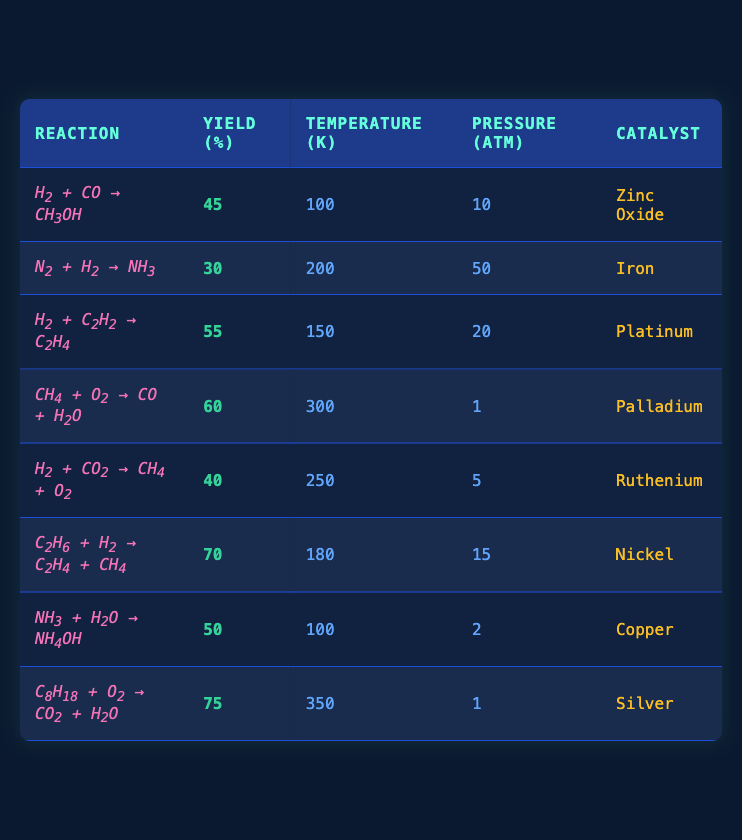What is the yield of the reaction involving H2 and CO? The yield for the reaction "H2 + CO -> CH3OH" is listed directly in the table as 45%.
Answer: 45% What catalyst is used in the reaction producing CH3OH? The reaction "H2 + CO -> CH3OH" uses Zinc Oxide as the catalyst, which is specified in the table.
Answer: Zinc Oxide Which reaction has the highest yield? The last row in the table shows that "C8H18 + O2 -> CO2 + H2O" has the highest yield of 75%.
Answer: 75% What is the average yield of all reactions? To find the average yield, sum all yields (45 + 30 + 55 + 60 + 40 + 70 + 50 + 75) = 425, then divide by the number of reactions (8): 425/8 = 53.125.
Answer: 53.125 Is there any reaction that has a yield of exactly 50%? Looking at the table, the yield of the reaction "NH3 + H2O -> NH4OH" is 50%, confirming that there is indeed a reaction with that yield.
Answer: Yes What is the difference in yield between the reaction with the highest yield and the one with the lowest yield? The highest yield is 75% from "C8H18 + O2 -> CO2 + H2O" and the lowest is 30% from "N2 + H2 -> NH3". The difference is 75 - 30 = 45.
Answer: 45 Which reaction occurs at the highest temperature? From the table, the reaction "C8H18 + O2 -> CO2 + H2O" occurs at the highest temperature of 350 K.
Answer: 350 K What is the total pressure in atm for all reactions combined? To find the total pressure, sum all pressures: 10 + 50 + 20 + 1 + 5 + 15 + 2 + 1 = 104 atm.
Answer: 104 atm Which reactions are conducted at pressures below 10 atm? The reactions "CH4 + O2 -> CO + H2O" (pressure 1 atm), "H2 + CO2 -> CH4 + O2" (pressure 5 atm), and "NH3 + H2O -> NH4OH" (pressure 2 atm) all have pressures below 10 atm.
Answer: 3 reactions Do any reactions utilize Iron as a catalyst? Yes, the reaction "N2 + H2 -> NH3" utilizes Iron as a catalyst, as stated in the table.
Answer: Yes 